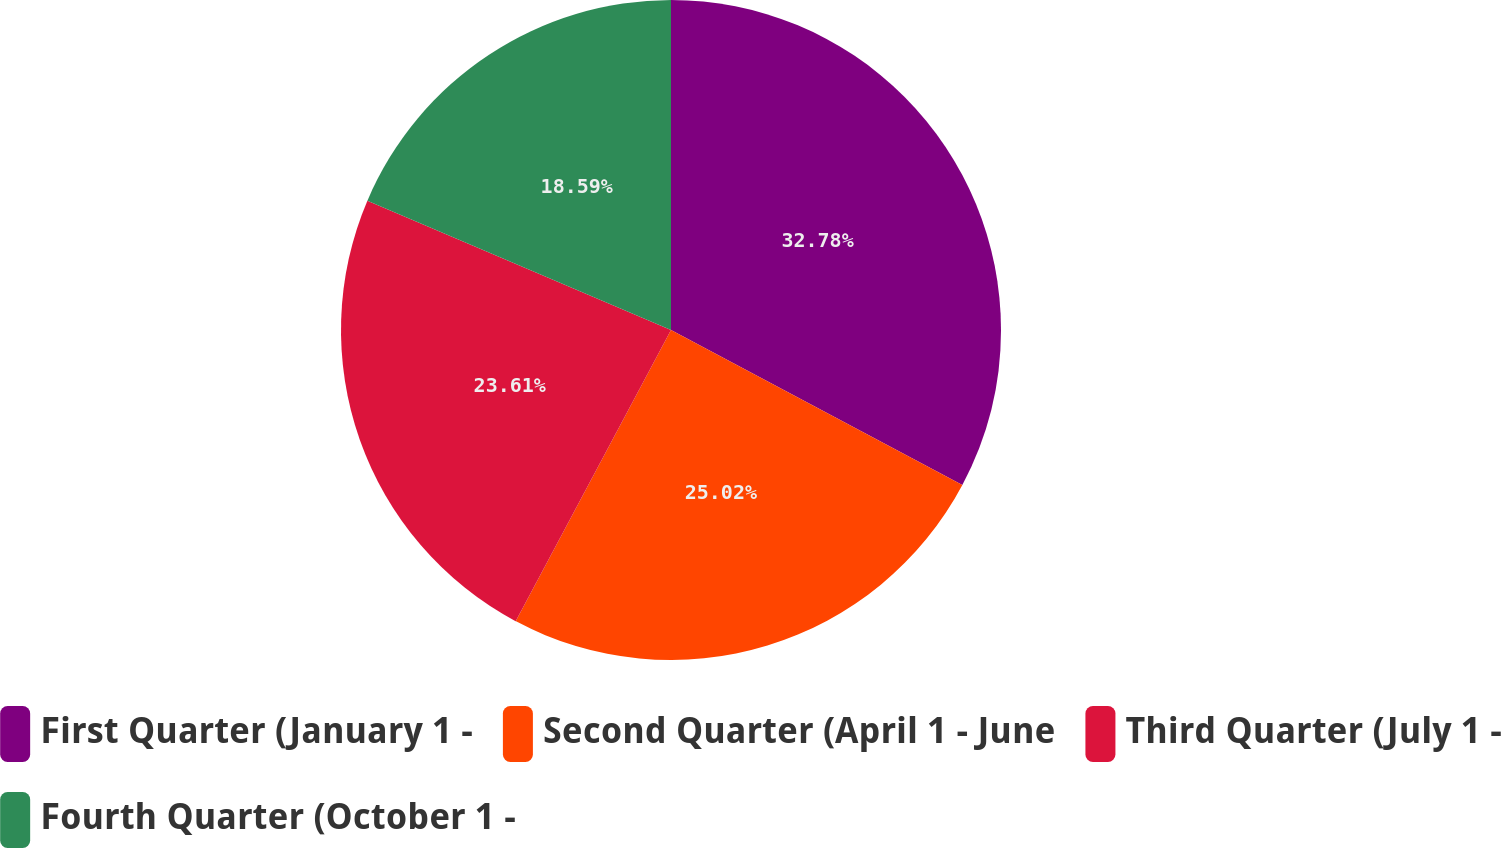Convert chart to OTSL. <chart><loc_0><loc_0><loc_500><loc_500><pie_chart><fcel>First Quarter (January 1 -<fcel>Second Quarter (April 1 - June<fcel>Third Quarter (July 1 -<fcel>Fourth Quarter (October 1 -<nl><fcel>32.78%<fcel>25.02%<fcel>23.61%<fcel>18.59%<nl></chart> 